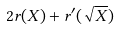Convert formula to latex. <formula><loc_0><loc_0><loc_500><loc_500>2 r ( X ) + r ^ { \prime } ( \sqrt { X } )</formula> 